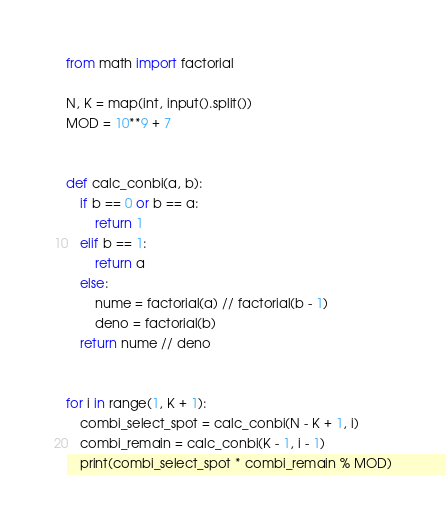Convert code to text. <code><loc_0><loc_0><loc_500><loc_500><_Python_>from math import factorial

N, K = map(int, input().split())
MOD = 10**9 + 7


def calc_conbi(a, b):
    if b == 0 or b == a:
        return 1
    elif b == 1:
        return a
    else:
        nume = factorial(a) // factorial(b - 1)
        deno = factorial(b)
    return nume // deno


for i in range(1, K + 1):
    combi_select_spot = calc_conbi(N - K + 1, i)
    combi_remain = calc_conbi(K - 1, i - 1)
    print(combi_select_spot * combi_remain % MOD)
</code> 